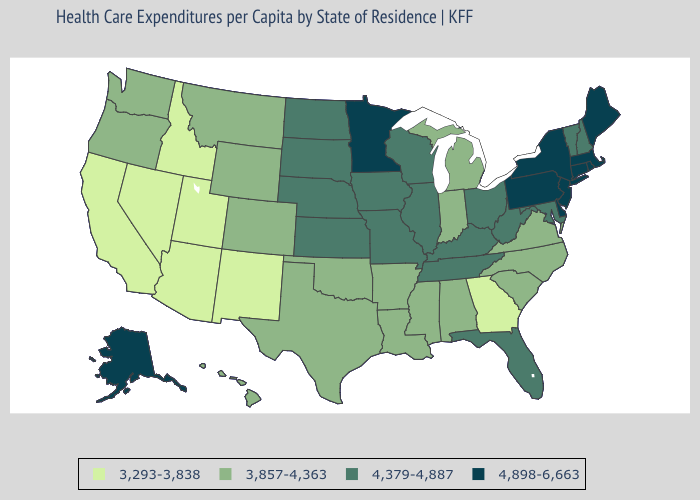What is the highest value in states that border Iowa?
Answer briefly. 4,898-6,663. Does Texas have a lower value than Wyoming?
Keep it brief. No. Which states have the highest value in the USA?
Write a very short answer. Alaska, Connecticut, Delaware, Maine, Massachusetts, Minnesota, New Jersey, New York, Pennsylvania, Rhode Island. Name the states that have a value in the range 4,379-4,887?
Be succinct. Florida, Illinois, Iowa, Kansas, Kentucky, Maryland, Missouri, Nebraska, New Hampshire, North Dakota, Ohio, South Dakota, Tennessee, Vermont, West Virginia, Wisconsin. What is the value of Maine?
Quick response, please. 4,898-6,663. Among the states that border Missouri , does Arkansas have the lowest value?
Answer briefly. Yes. What is the value of Maine?
Quick response, please. 4,898-6,663. What is the lowest value in states that border Montana?
Quick response, please. 3,293-3,838. Among the states that border Michigan , which have the highest value?
Keep it brief. Ohio, Wisconsin. What is the value of New Mexico?
Quick response, please. 3,293-3,838. Name the states that have a value in the range 3,293-3,838?
Be succinct. Arizona, California, Georgia, Idaho, Nevada, New Mexico, Utah. What is the lowest value in the Northeast?
Keep it brief. 4,379-4,887. What is the value of Nebraska?
Give a very brief answer. 4,379-4,887. Does Minnesota have the highest value in the MidWest?
Short answer required. Yes. Name the states that have a value in the range 4,898-6,663?
Short answer required. Alaska, Connecticut, Delaware, Maine, Massachusetts, Minnesota, New Jersey, New York, Pennsylvania, Rhode Island. 